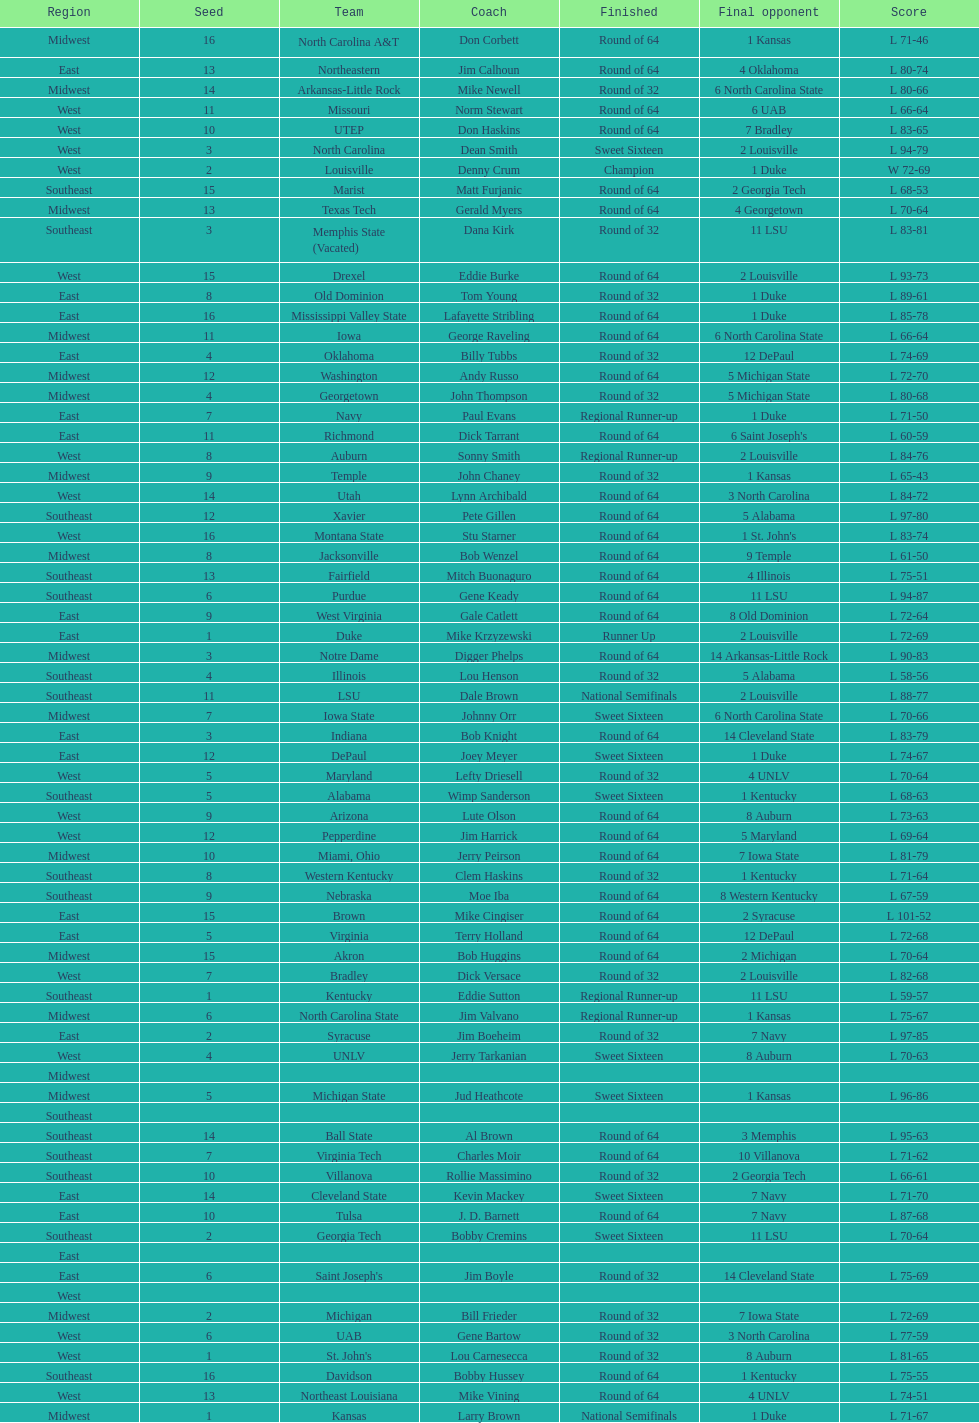North carolina and unlv each made it to which round? Sweet Sixteen. 